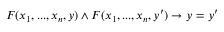Convert formula to latex. <formula><loc_0><loc_0><loc_500><loc_500>F ( x _ { 1 } , \dots , x _ { n } , y ) \land F ( x _ { 1 } , \dots , x _ { n } , y ^ { \prime } ) \rightarrow y = y ^ { \prime }</formula> 